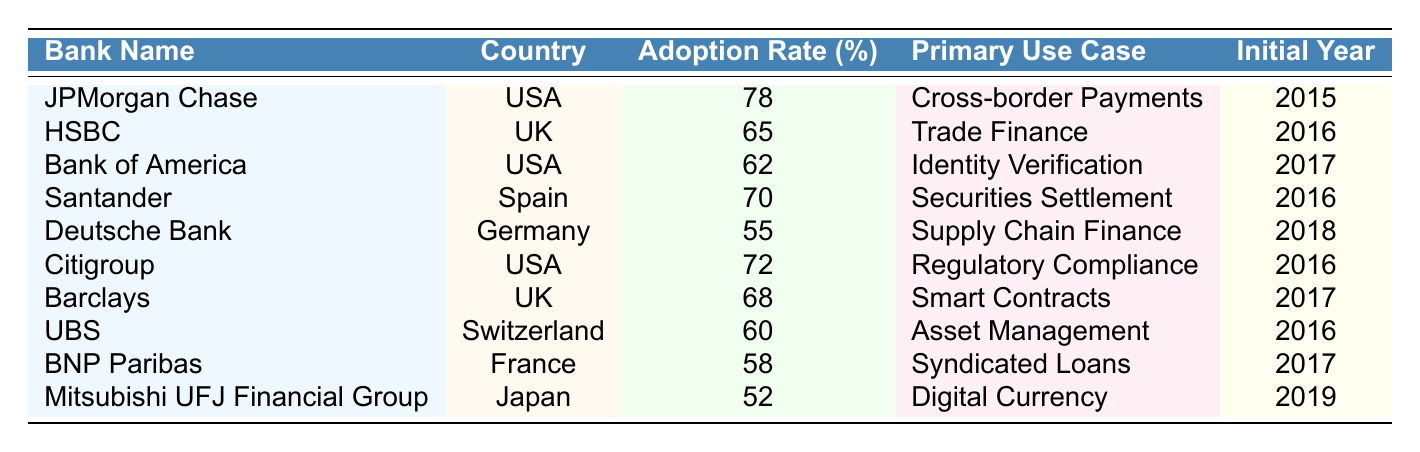What is the highest blockchain adoption rate among the banks listed? Looking at the "Blockchain Adoption Rate (%)" column, the highest value is 78, which belongs to JPMorgan Chase.
Answer: 78 Which bank has the lowest blockchain adoption rate? The lowest adoption rate listed in the table is 52, associated with Mitsubishi UFJ Financial Group.
Answer: 52 How many banks have an adoption rate above 60%? The banks with adoption rates above 60% are JPMorgan Chase, HSBC, Citigroup, Santander, and Barclays. There are 5 such banks.
Answer: 5 Which country has the bank with the highest blockchain adoption rate? The bank with the highest adoption rate, JPMorgan Chase, is from the USA.
Answer: USA Is there any bank that uses blockchain for Digital Currency? Yes, Mitsubishi UFJ Financial Group uses blockchain for Digital Currency, according to the "Primary Blockchain Use Case" column.
Answer: Yes What is the average blockchain adoption rate of banks from the USA? The adoption rates for banks from the USA are 78, 62, and 72. The average is calculated as (78 + 62 + 72) / 3 = 70.67.
Answer: 70.67 Which primary use case has the most banks implementing blockchain? By reviewing the use cases, several banks share distinct use cases, with "Regulatory Compliance" and "Trade Finance" each listed for two banks, while others are unique.
Answer: Trade Finance and Regulatory Compliance Which bank from Germany has implemented blockchain and what is the adoption rate? The bank from Germany listed is Deutsche Bank, which has an adoption rate of 55%.
Answer: Deutsche Bank, 55 What is the difference in adoption rates between the bank with the highest and the lowest adoption rates? The difference is calculated as 78 (JPMorgan Chase) - 52 (Mitsubishi UFJ Financial Group) = 26.
Answer: 26 How many banks in the table have started implementing blockchain in the year 2016? The banks that implemented blockchain in 2016 are HSBC, Citigroup, Santander, and UBS, totaling 4 banks.
Answer: 4 